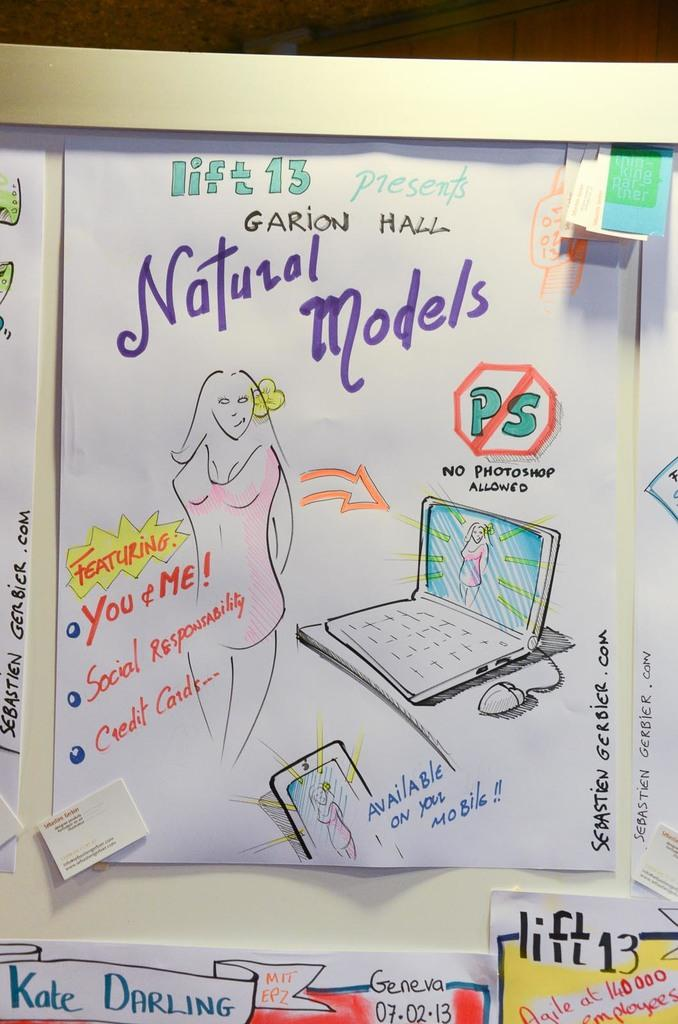What is featured on the poster in the image? There is a poster with natural models in the image. Can you describe the person in the image? There is a person in the image. What electronic device is visible in the image? There is a laptop in the image. What is connected to the laptop in the image? There is a mouse connected to the laptop in the image. What type of communication device is present in the image? There is a mobile in the image. What type of tail can be seen on the person in the image? There is no tail present on the person in the image. What time of day is depicted in the image? The time of day is not specified in the image. 